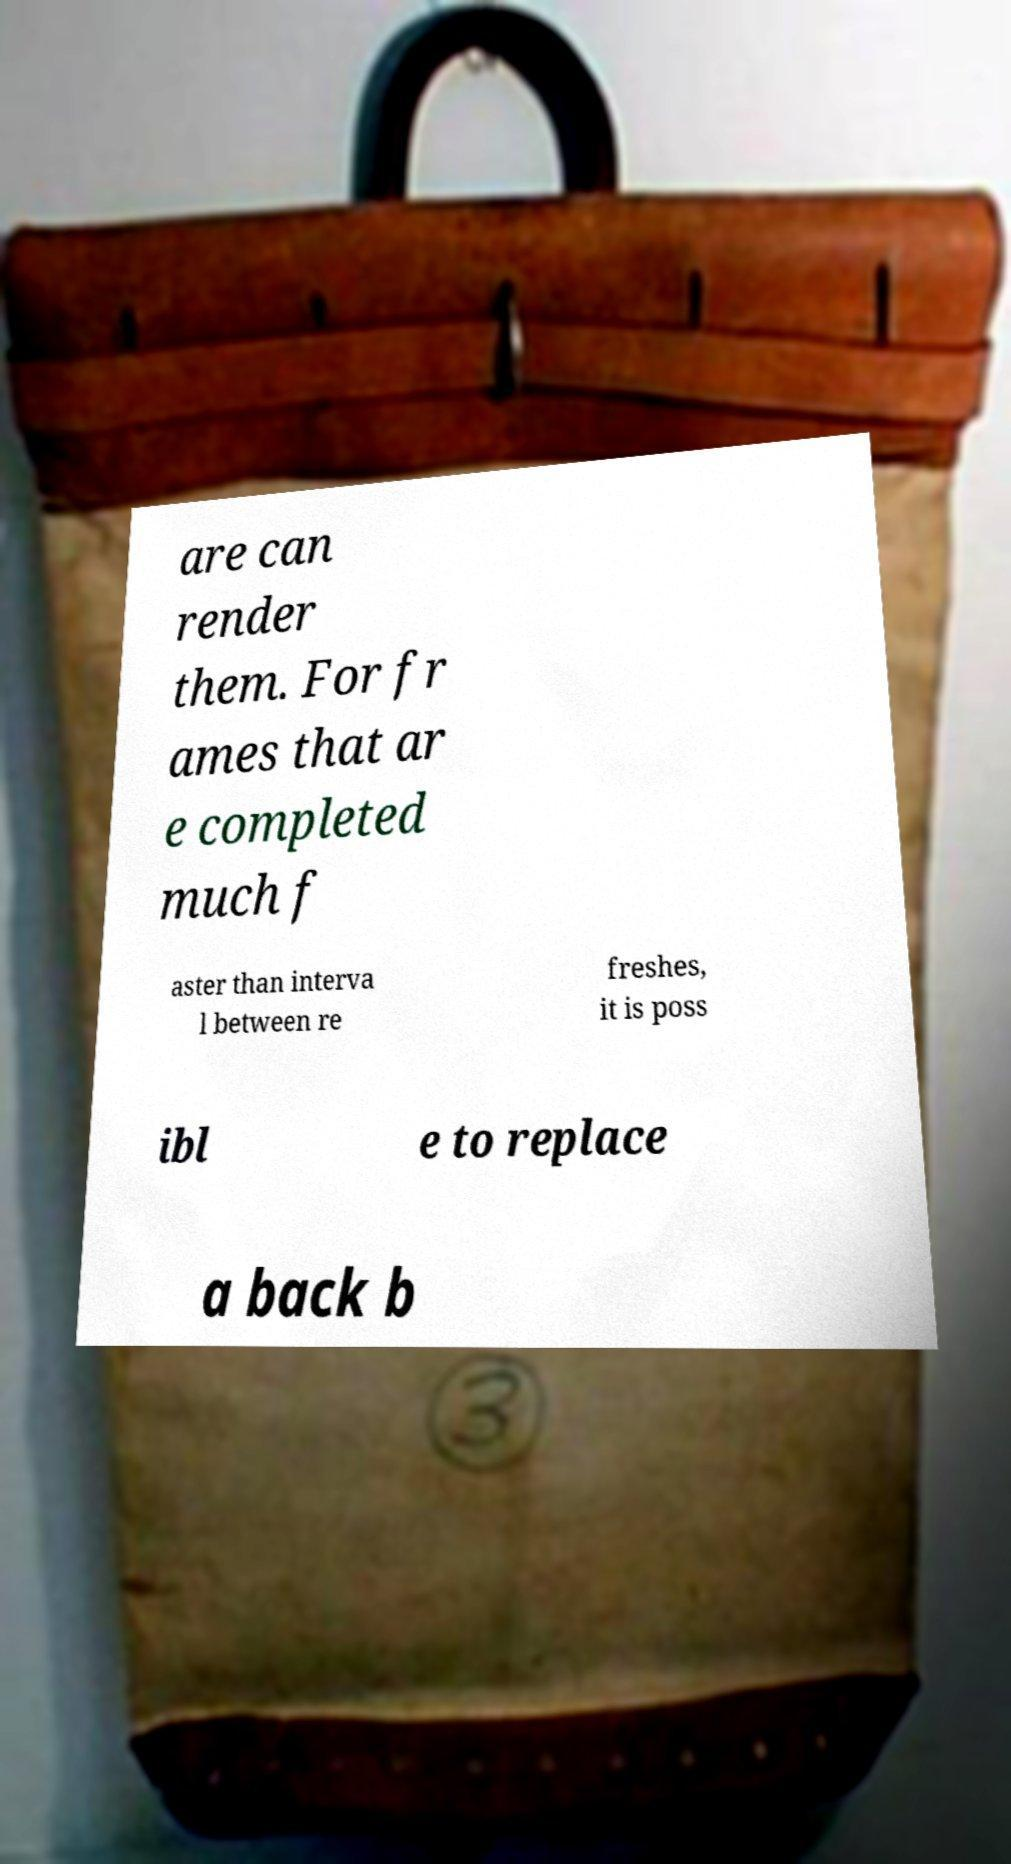Could you extract and type out the text from this image? are can render them. For fr ames that ar e completed much f aster than interva l between re freshes, it is poss ibl e to replace a back b 